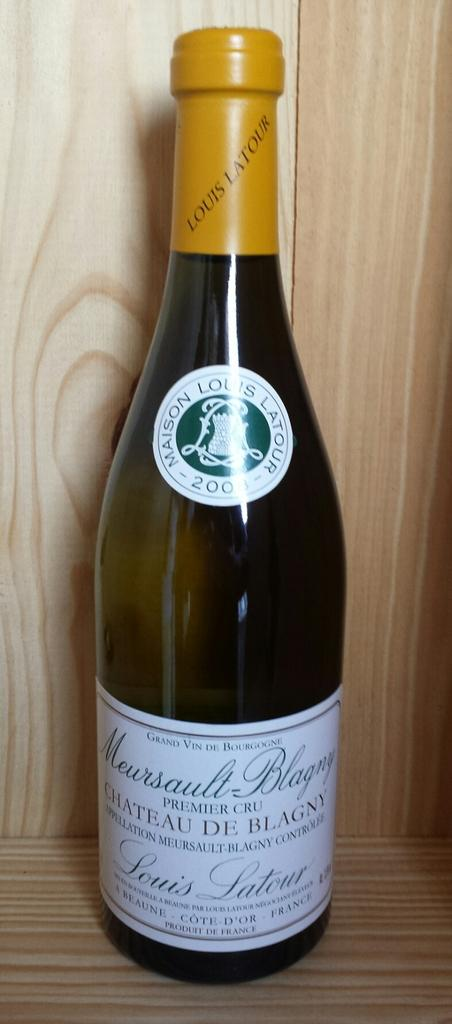<image>
Present a compact description of the photo's key features. A bottle of Louis Latour wine sits on a wood surface. 